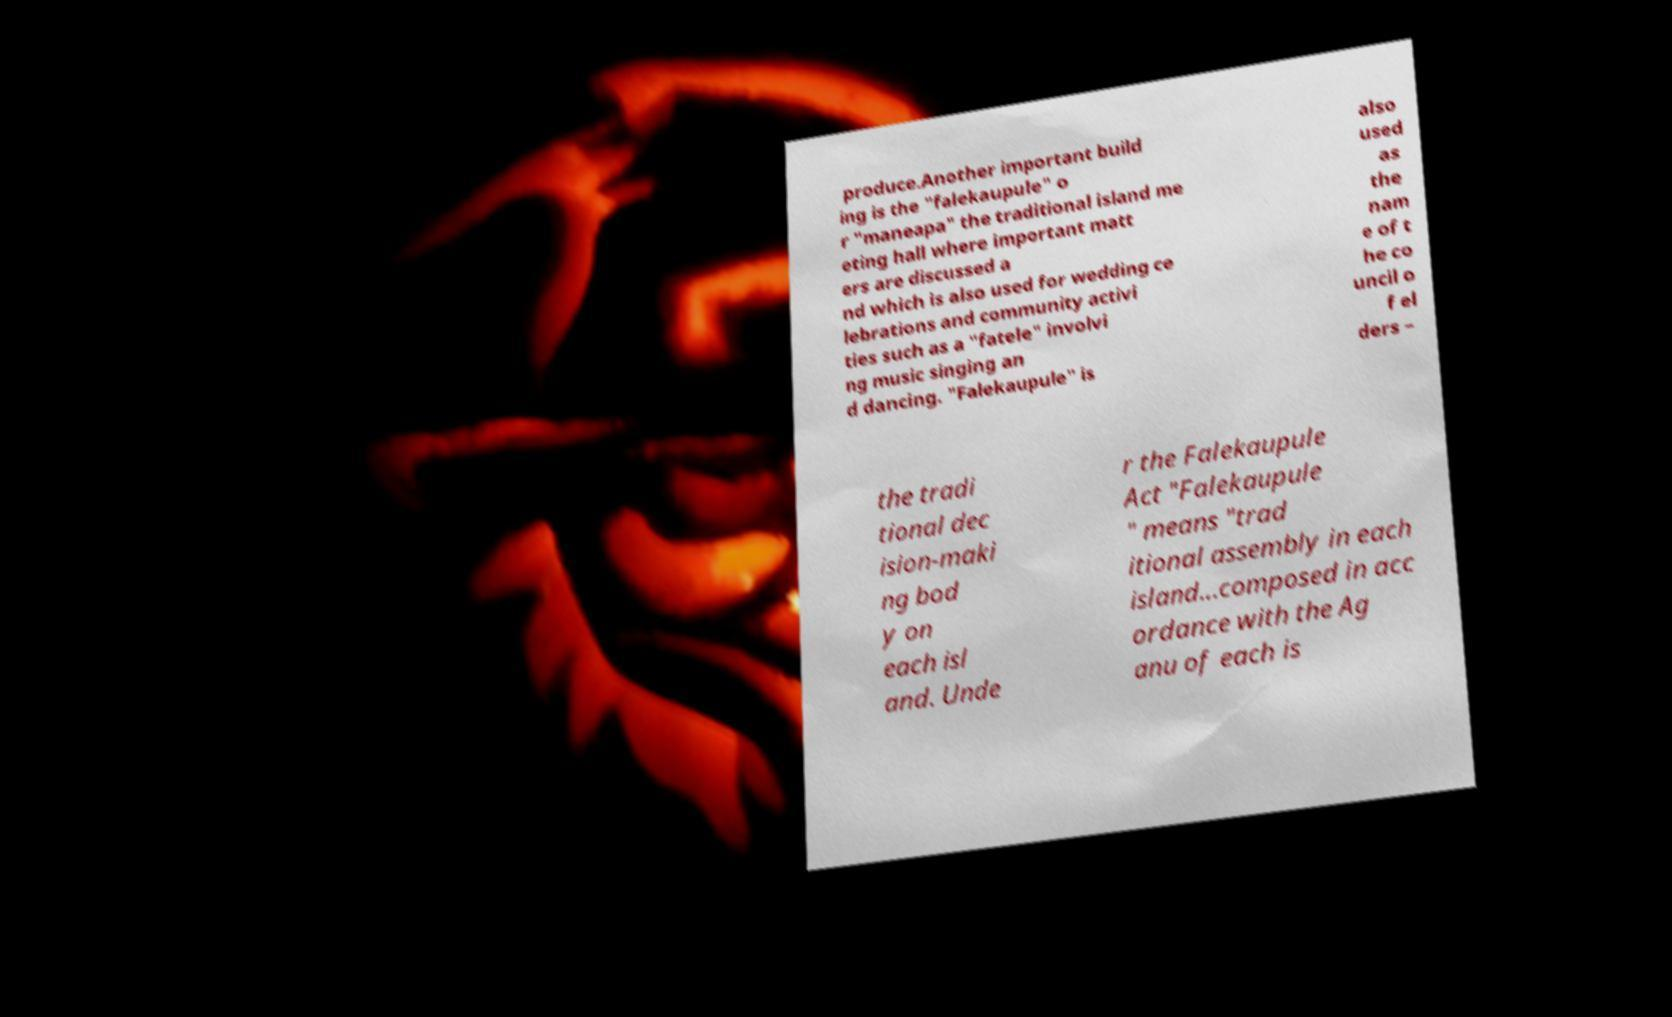What messages or text are displayed in this image? I need them in a readable, typed format. produce.Another important build ing is the "falekaupule" o r "maneapa" the traditional island me eting hall where important matt ers are discussed a nd which is also used for wedding ce lebrations and community activi ties such as a "fatele" involvi ng music singing an d dancing. "Falekaupule" is also used as the nam e of t he co uncil o f el ders – the tradi tional dec ision-maki ng bod y on each isl and. Unde r the Falekaupule Act "Falekaupule " means "trad itional assembly in each island...composed in acc ordance with the Ag anu of each is 